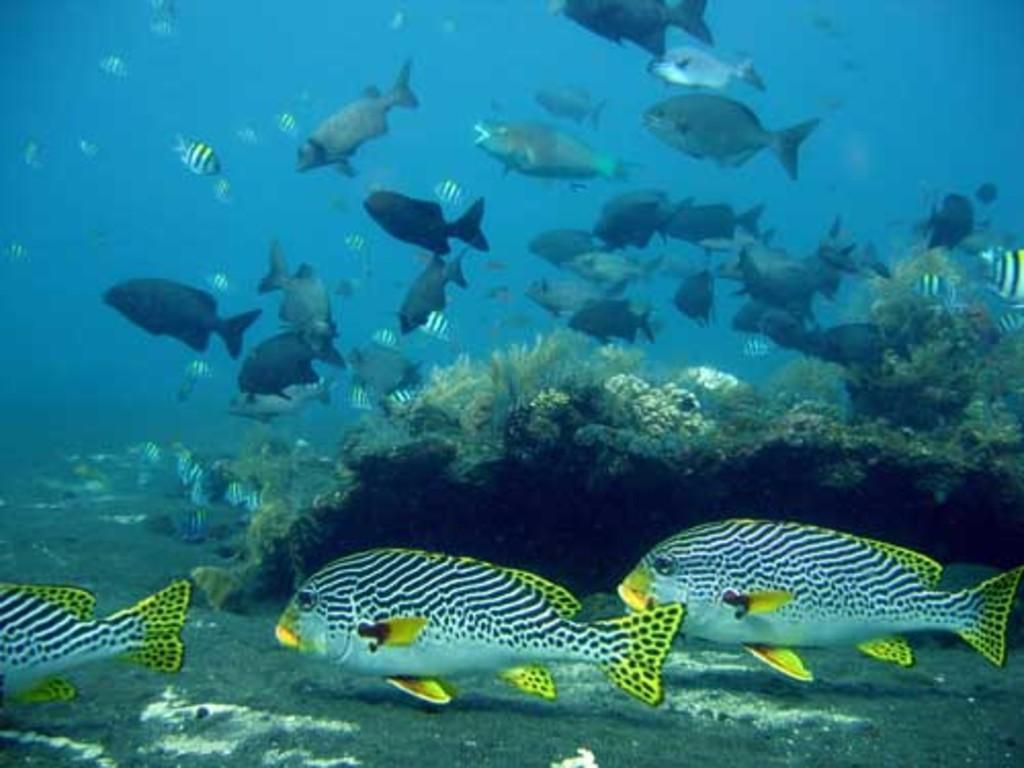Describe this image in one or two sentences. In this image, I can see different species of fishes, which are under the water. These are the rocks and corals, which are under the water. 